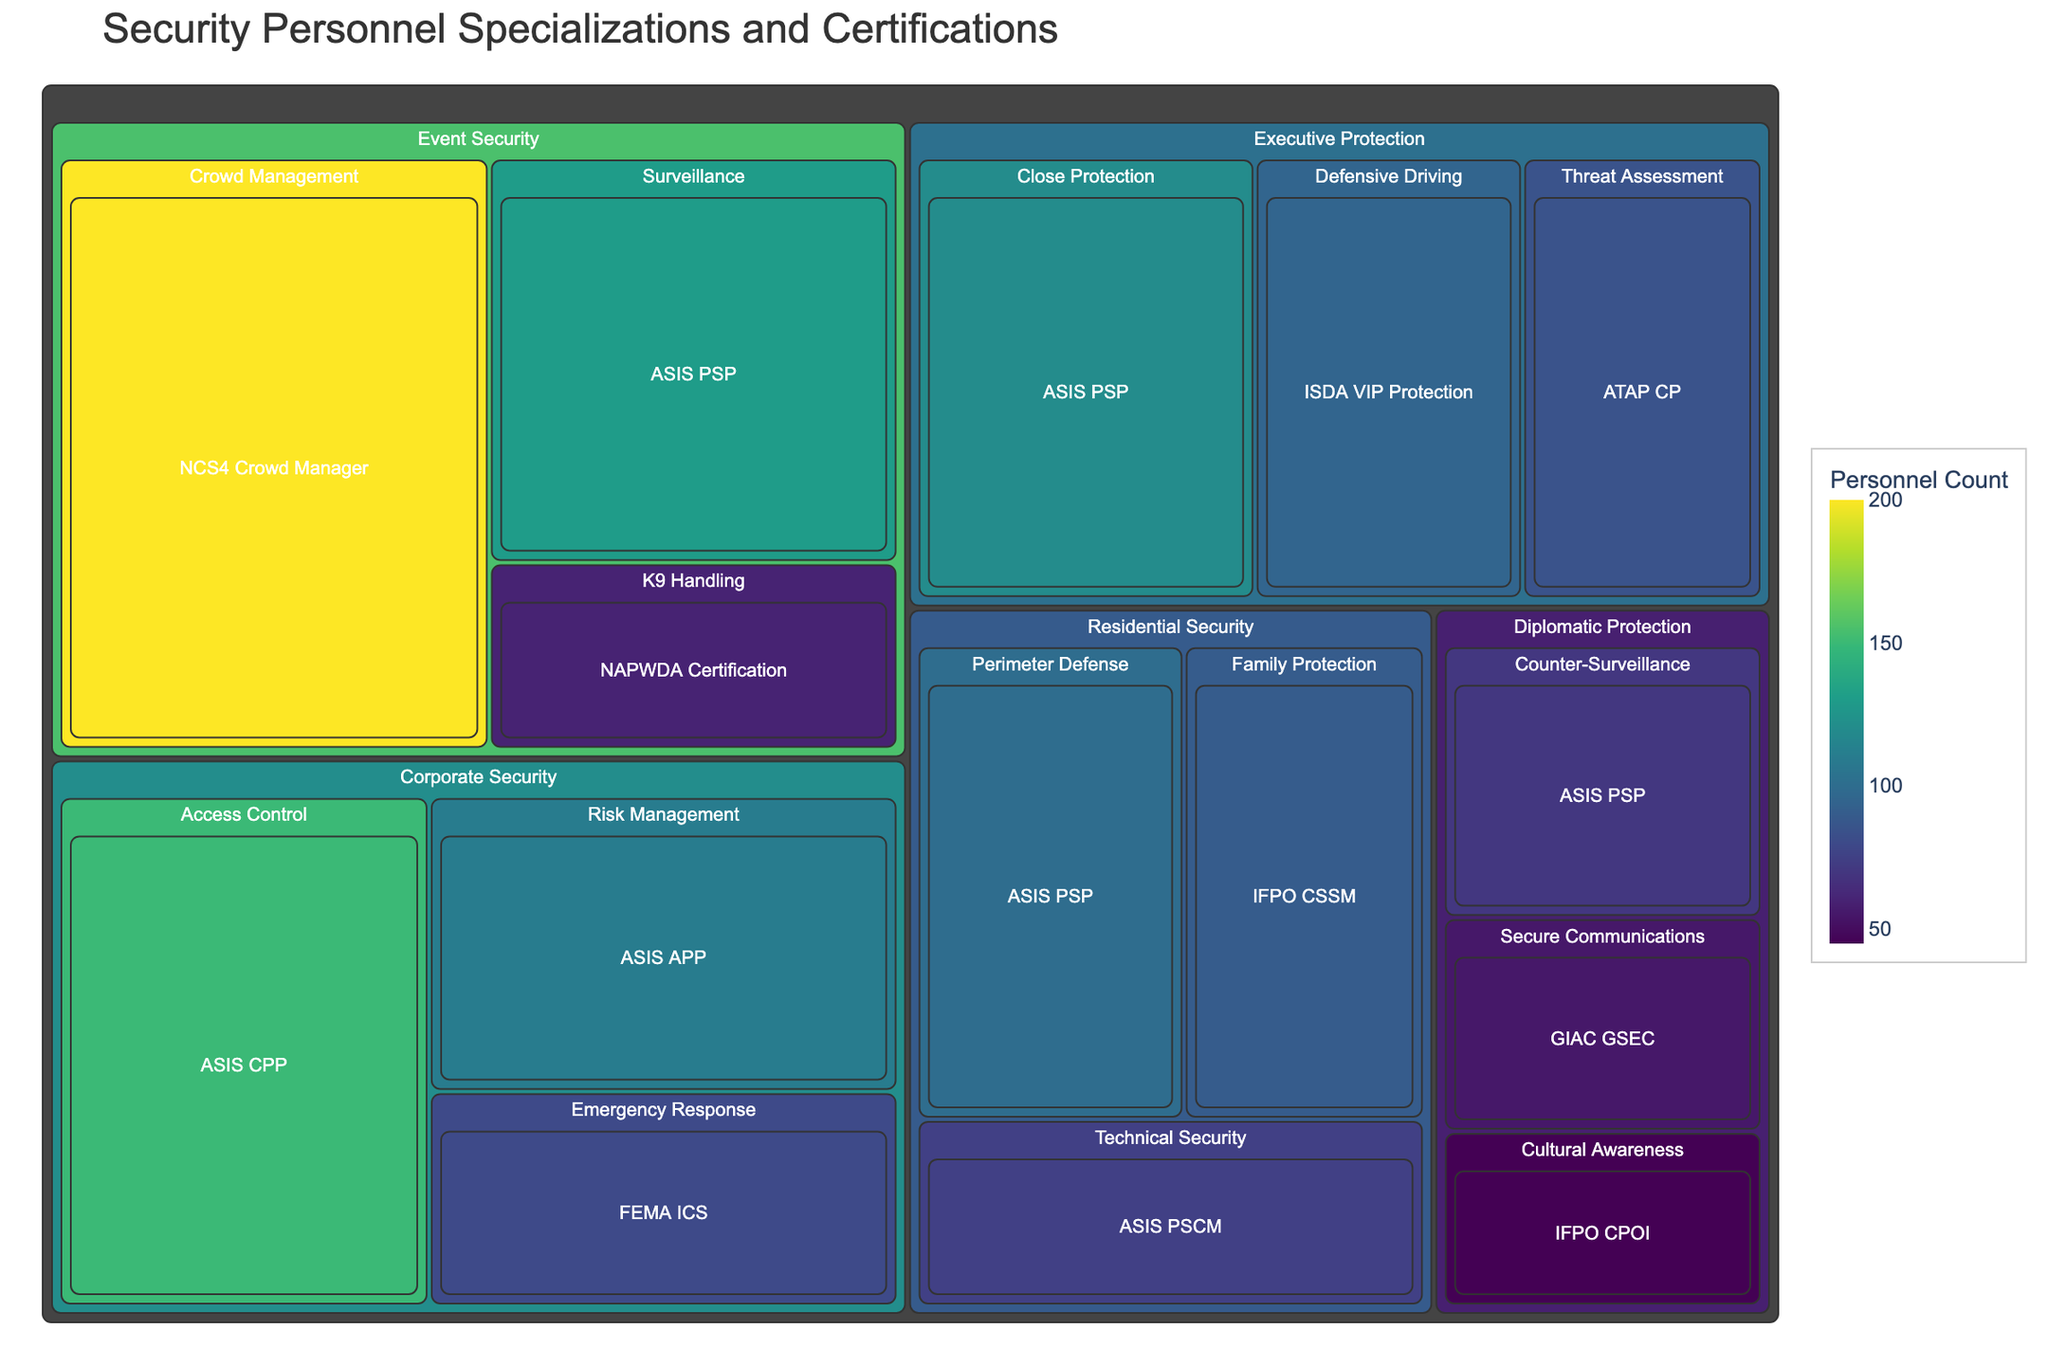What's the title of the treemap? The title is placed at the top of the treemap. By reading, it identifies the content of the treemap.
Answer: Security Personnel Specializations and Certifications Which security level has the highest personnel count? To find the security level with the highest personnel count, sum the personnel counts for each specialization within every security level. The largest sum will indicate the highest personnel level.
Answer: Event Security How many personnel are specializing in Threat Assessment under Executive Protection? Look for the Threat Assessment specialization under the Executive Protection security level. The personnel count is directly displayed on the treemap.
Answer: 85 Compare the personnel count of ASIS PSP certification between executive and residential security levels. Locate ASIS PSP certification within both Executive Protection and Residential Security levels. Sum the personnel counts for these certifications in each level. Executive Protection has 120, and Residential Security has 100.
Answer: Executive Protection has more, 120 compared to 100 in Residential Security Which certification under Corporate Security has the highest personnel count? Identify the different certifications under Corporate Security and compare their personnel counts. The one with the highest number is the answer.
Answer: ASIS CPP What's the total number of personnel under K9 Handling specialization in Event Security? Locate the K9 Handling specialization within the Event Security level and read the personnel count directly from the treemap.
Answer: 60 What is the average personnel count of all certifications in Residential Security? Identify all personnel counts associated with certifications under Residential Security. Calculate the average by summing these counts and dividing by the number of certifications (100 + 75 + 90)/3 = 88.33.
Answer: 88.33 Which security level has the least variety in specializations? Count the number of specializations listed under each security level. The level with the fewest specializations mentioned has the least variety.
Answer: Diplomatic Protection How does the personnel count for NAPWDA Certification compare with IFPO CSSM in terms of difference? NAPWDA Certification is found under Event Security with 60 personnel and IFPO CSSM under Residential Security with 90. Calculate the difference as 90 - 60 = 30.
Answer: 30 What is the sum of personnel counts for certifications starting with "ASIS" across all security levels? Add personnel counts for all certifications that start with "ASIS" from each security level: ASIS PSP (120 + 130 + 70 + 100), ASIS CPP (150), ASIS APP (110), ASIS PSCM (75). The sum is 130 + 150 + 110 + 80 + 75 = 665.
Answer: 665 